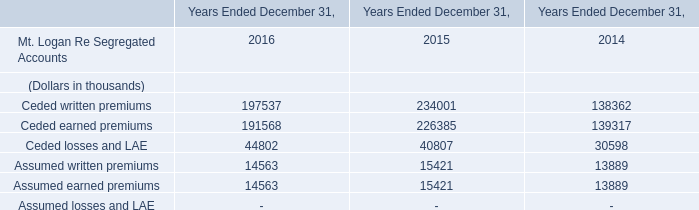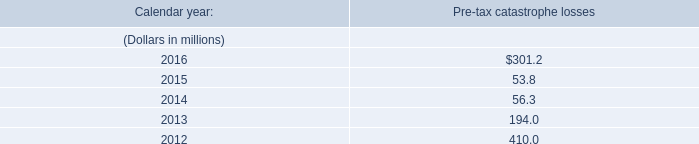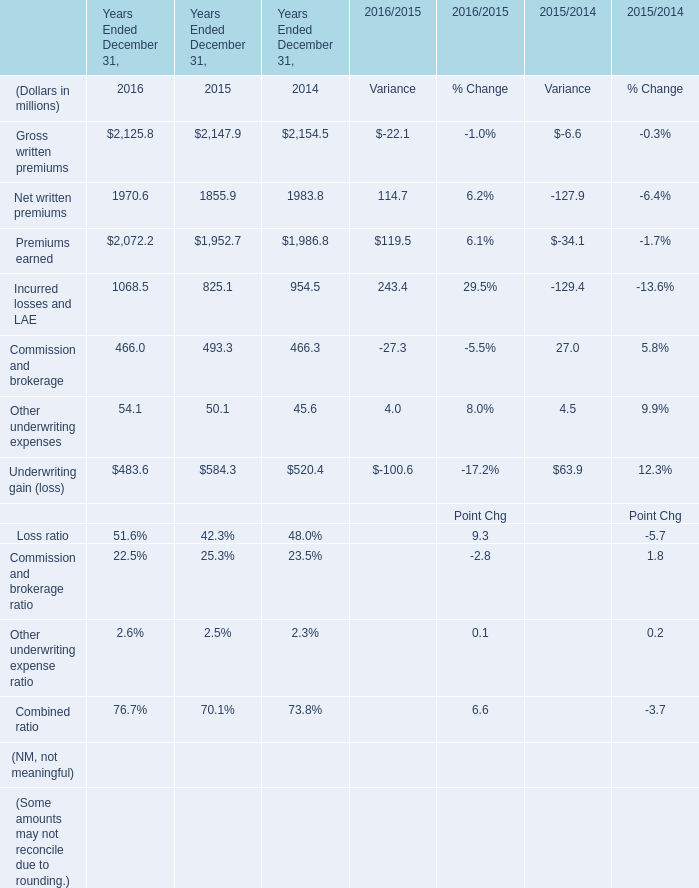What is the growing rate of Ceded losses and LAE in Table 0 in the years with the least Premiums earned in Table 2? 
Computations: ((40807 - 30598) / 30598)
Answer: 0.33365. 